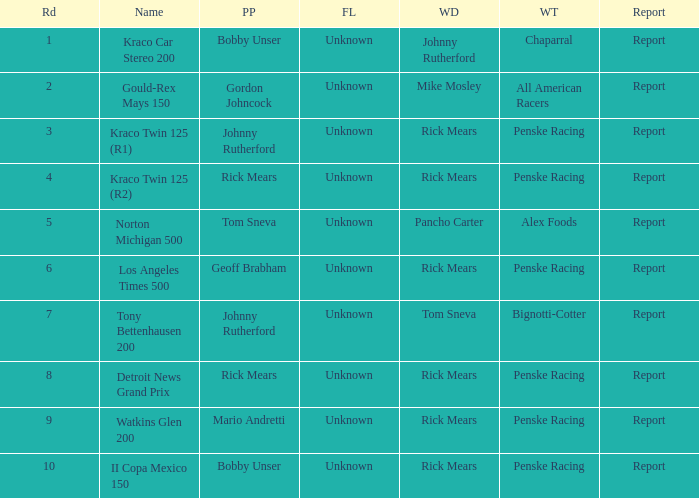How many fastest laps were there for a rd that equals 10? 1.0. 